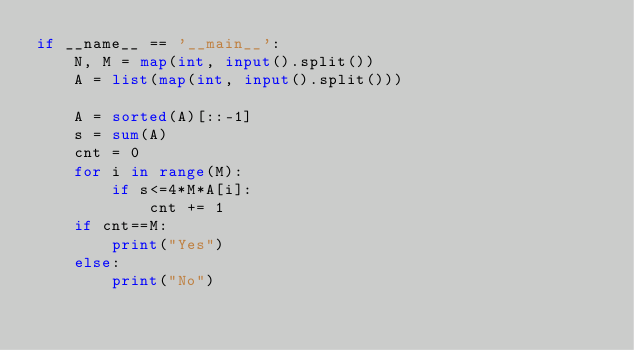<code> <loc_0><loc_0><loc_500><loc_500><_Python_>if __name__ == '__main__':
    N, M = map(int, input().split())
    A = list(map(int, input().split()))

    A = sorted(A)[::-1]
    s = sum(A)
    cnt = 0
    for i in range(M):
        if s<=4*M*A[i]:
            cnt += 1
    if cnt==M:
        print("Yes")
    else:
        print("No")
    
</code> 